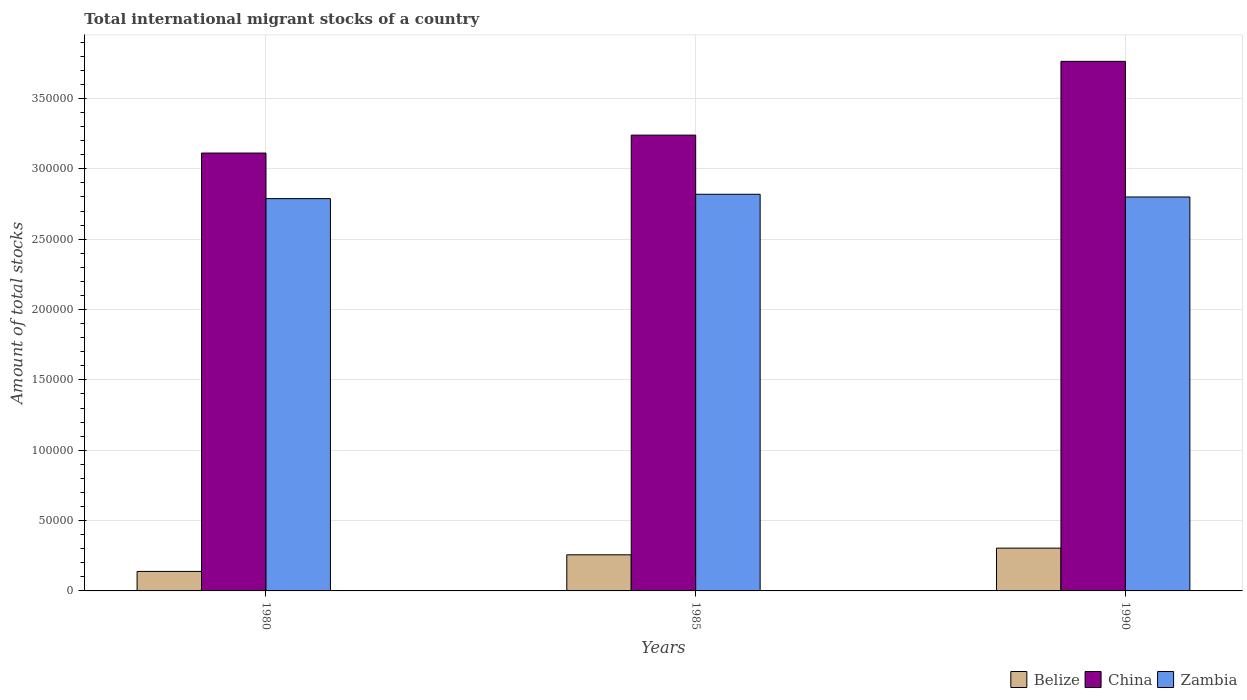How many different coloured bars are there?
Provide a short and direct response. 3. Are the number of bars on each tick of the X-axis equal?
Give a very brief answer. Yes. How many bars are there on the 1st tick from the left?
Make the answer very short. 3. How many bars are there on the 2nd tick from the right?
Your answer should be very brief. 3. What is the amount of total stocks in in China in 1985?
Keep it short and to the point. 3.24e+05. Across all years, what is the maximum amount of total stocks in in Belize?
Your answer should be very brief. 3.04e+04. Across all years, what is the minimum amount of total stocks in in Belize?
Provide a short and direct response. 1.39e+04. What is the total amount of total stocks in in Belize in the graph?
Give a very brief answer. 6.99e+04. What is the difference between the amount of total stocks in in Belize in 1980 and that in 1985?
Provide a succinct answer. -1.18e+04. What is the difference between the amount of total stocks in in Zambia in 1980 and the amount of total stocks in in China in 1990?
Make the answer very short. -9.76e+04. What is the average amount of total stocks in in Belize per year?
Provide a succinct answer. 2.33e+04. In the year 1985, what is the difference between the amount of total stocks in in Zambia and amount of total stocks in in Belize?
Provide a short and direct response. 2.56e+05. What is the ratio of the amount of total stocks in in Belize in 1980 to that in 1990?
Your answer should be very brief. 0.46. What is the difference between the highest and the second highest amount of total stocks in in Zambia?
Make the answer very short. 1937. What is the difference between the highest and the lowest amount of total stocks in in China?
Offer a terse response. 6.52e+04. Is the sum of the amount of total stocks in in Belize in 1985 and 1990 greater than the maximum amount of total stocks in in Zambia across all years?
Your response must be concise. No. What does the 2nd bar from the left in 1980 represents?
Offer a terse response. China. What does the 1st bar from the right in 1985 represents?
Your answer should be very brief. Zambia. Are all the bars in the graph horizontal?
Ensure brevity in your answer.  No. How many years are there in the graph?
Make the answer very short. 3. What is the difference between two consecutive major ticks on the Y-axis?
Your answer should be compact. 5.00e+04. Are the values on the major ticks of Y-axis written in scientific E-notation?
Offer a very short reply. No. Does the graph contain any zero values?
Provide a short and direct response. No. Where does the legend appear in the graph?
Provide a succinct answer. Bottom right. How many legend labels are there?
Provide a succinct answer. 3. How are the legend labels stacked?
Ensure brevity in your answer.  Horizontal. What is the title of the graph?
Ensure brevity in your answer.  Total international migrant stocks of a country. What is the label or title of the Y-axis?
Provide a succinct answer. Amount of total stocks. What is the Amount of total stocks in Belize in 1980?
Your answer should be compact. 1.39e+04. What is the Amount of total stocks of China in 1980?
Keep it short and to the point. 3.11e+05. What is the Amount of total stocks of Zambia in 1980?
Make the answer very short. 2.79e+05. What is the Amount of total stocks in Belize in 1985?
Offer a terse response. 2.57e+04. What is the Amount of total stocks of China in 1985?
Your response must be concise. 3.24e+05. What is the Amount of total stocks of Zambia in 1985?
Make the answer very short. 2.82e+05. What is the Amount of total stocks of Belize in 1990?
Keep it short and to the point. 3.04e+04. What is the Amount of total stocks of China in 1990?
Provide a short and direct response. 3.76e+05. What is the Amount of total stocks in Zambia in 1990?
Your answer should be very brief. 2.80e+05. Across all years, what is the maximum Amount of total stocks of Belize?
Give a very brief answer. 3.04e+04. Across all years, what is the maximum Amount of total stocks of China?
Make the answer very short. 3.76e+05. Across all years, what is the maximum Amount of total stocks of Zambia?
Keep it short and to the point. 2.82e+05. Across all years, what is the minimum Amount of total stocks of Belize?
Keep it short and to the point. 1.39e+04. Across all years, what is the minimum Amount of total stocks of China?
Your answer should be very brief. 3.11e+05. Across all years, what is the minimum Amount of total stocks of Zambia?
Offer a very short reply. 2.79e+05. What is the total Amount of total stocks in Belize in the graph?
Your response must be concise. 6.99e+04. What is the total Amount of total stocks in China in the graph?
Your answer should be very brief. 1.01e+06. What is the total Amount of total stocks in Zambia in the graph?
Provide a short and direct response. 8.41e+05. What is the difference between the Amount of total stocks in Belize in 1980 and that in 1985?
Your answer should be very brief. -1.18e+04. What is the difference between the Amount of total stocks in China in 1980 and that in 1985?
Keep it short and to the point. -1.27e+04. What is the difference between the Amount of total stocks in Zambia in 1980 and that in 1985?
Your answer should be compact. -3108. What is the difference between the Amount of total stocks of Belize in 1980 and that in 1990?
Ensure brevity in your answer.  -1.65e+04. What is the difference between the Amount of total stocks in China in 1980 and that in 1990?
Offer a terse response. -6.52e+04. What is the difference between the Amount of total stocks in Zambia in 1980 and that in 1990?
Ensure brevity in your answer.  -1171. What is the difference between the Amount of total stocks in Belize in 1985 and that in 1990?
Offer a very short reply. -4731. What is the difference between the Amount of total stocks of China in 1985 and that in 1990?
Your answer should be very brief. -5.24e+04. What is the difference between the Amount of total stocks of Zambia in 1985 and that in 1990?
Offer a very short reply. 1937. What is the difference between the Amount of total stocks of Belize in 1980 and the Amount of total stocks of China in 1985?
Keep it short and to the point. -3.10e+05. What is the difference between the Amount of total stocks in Belize in 1980 and the Amount of total stocks in Zambia in 1985?
Your answer should be compact. -2.68e+05. What is the difference between the Amount of total stocks of China in 1980 and the Amount of total stocks of Zambia in 1985?
Give a very brief answer. 2.93e+04. What is the difference between the Amount of total stocks of Belize in 1980 and the Amount of total stocks of China in 1990?
Offer a terse response. -3.63e+05. What is the difference between the Amount of total stocks in Belize in 1980 and the Amount of total stocks in Zambia in 1990?
Give a very brief answer. -2.66e+05. What is the difference between the Amount of total stocks in China in 1980 and the Amount of total stocks in Zambia in 1990?
Offer a very short reply. 3.12e+04. What is the difference between the Amount of total stocks in Belize in 1985 and the Amount of total stocks in China in 1990?
Your response must be concise. -3.51e+05. What is the difference between the Amount of total stocks in Belize in 1985 and the Amount of total stocks in Zambia in 1990?
Offer a terse response. -2.54e+05. What is the difference between the Amount of total stocks of China in 1985 and the Amount of total stocks of Zambia in 1990?
Offer a very short reply. 4.40e+04. What is the average Amount of total stocks of Belize per year?
Make the answer very short. 2.33e+04. What is the average Amount of total stocks in China per year?
Give a very brief answer. 3.37e+05. What is the average Amount of total stocks in Zambia per year?
Give a very brief answer. 2.80e+05. In the year 1980, what is the difference between the Amount of total stocks of Belize and Amount of total stocks of China?
Your answer should be compact. -2.97e+05. In the year 1980, what is the difference between the Amount of total stocks in Belize and Amount of total stocks in Zambia?
Your answer should be compact. -2.65e+05. In the year 1980, what is the difference between the Amount of total stocks in China and Amount of total stocks in Zambia?
Your response must be concise. 3.24e+04. In the year 1985, what is the difference between the Amount of total stocks of Belize and Amount of total stocks of China?
Your response must be concise. -2.98e+05. In the year 1985, what is the difference between the Amount of total stocks of Belize and Amount of total stocks of Zambia?
Your response must be concise. -2.56e+05. In the year 1985, what is the difference between the Amount of total stocks in China and Amount of total stocks in Zambia?
Keep it short and to the point. 4.20e+04. In the year 1990, what is the difference between the Amount of total stocks in Belize and Amount of total stocks in China?
Make the answer very short. -3.46e+05. In the year 1990, what is the difference between the Amount of total stocks in Belize and Amount of total stocks in Zambia?
Ensure brevity in your answer.  -2.50e+05. In the year 1990, what is the difference between the Amount of total stocks of China and Amount of total stocks of Zambia?
Your answer should be very brief. 9.64e+04. What is the ratio of the Amount of total stocks of Belize in 1980 to that in 1985?
Your answer should be compact. 0.54. What is the ratio of the Amount of total stocks in China in 1980 to that in 1985?
Keep it short and to the point. 0.96. What is the ratio of the Amount of total stocks in Zambia in 1980 to that in 1985?
Keep it short and to the point. 0.99. What is the ratio of the Amount of total stocks in Belize in 1980 to that in 1990?
Your answer should be compact. 0.46. What is the ratio of the Amount of total stocks in China in 1980 to that in 1990?
Keep it short and to the point. 0.83. What is the ratio of the Amount of total stocks of Belize in 1985 to that in 1990?
Provide a succinct answer. 0.84. What is the ratio of the Amount of total stocks of China in 1985 to that in 1990?
Your answer should be compact. 0.86. What is the ratio of the Amount of total stocks in Zambia in 1985 to that in 1990?
Your answer should be very brief. 1.01. What is the difference between the highest and the second highest Amount of total stocks in Belize?
Ensure brevity in your answer.  4731. What is the difference between the highest and the second highest Amount of total stocks of China?
Keep it short and to the point. 5.24e+04. What is the difference between the highest and the second highest Amount of total stocks in Zambia?
Your response must be concise. 1937. What is the difference between the highest and the lowest Amount of total stocks of Belize?
Keep it short and to the point. 1.65e+04. What is the difference between the highest and the lowest Amount of total stocks of China?
Offer a very short reply. 6.52e+04. What is the difference between the highest and the lowest Amount of total stocks of Zambia?
Offer a very short reply. 3108. 